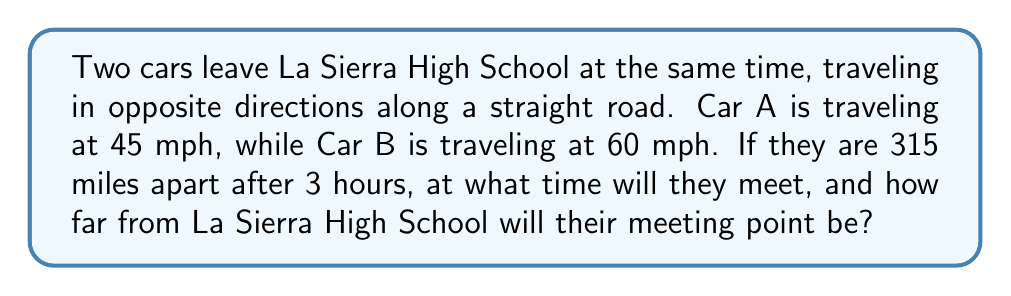Can you answer this question? Let's approach this step-by-step:

1) First, let's define our variables:
   $t$ = time (in hours) when the cars meet
   $d_A$ = distance traveled by Car A
   $d_B$ = distance traveled by Car B

2) We know that distance = rate × time, so we can set up two equations:
   $d_A = 45t$
   $d_B = 60t$

3) We're told that after 3 hours, the cars are 315 miles apart. This means:
   $45(3) + 60(3) = 315$
   $135 + 180 = 315$

4) The total distance between the cars when they meet will be:
   $d_A + d_B = 45t + 60t = 105t$

5) We can set up an equation based on the fact that this total distance must equal 315 miles:
   $105t = 315$

6) Solving for $t$:
   $t = \frac{315}{105} = 3$ hours

7) To find the distance from La Sierra High School to the meeting point, we can use either car's equation:
   For Car A: $d_A = 45(3) = 135$ miles

Therefore, the cars will meet 3 hours after leaving La Sierra High School, and the meeting point will be 135 miles away from the school in the direction Car A was traveling.
Answer: The cars will meet 3 hours after departure, 135 miles from La Sierra High School in the direction of Car A. 